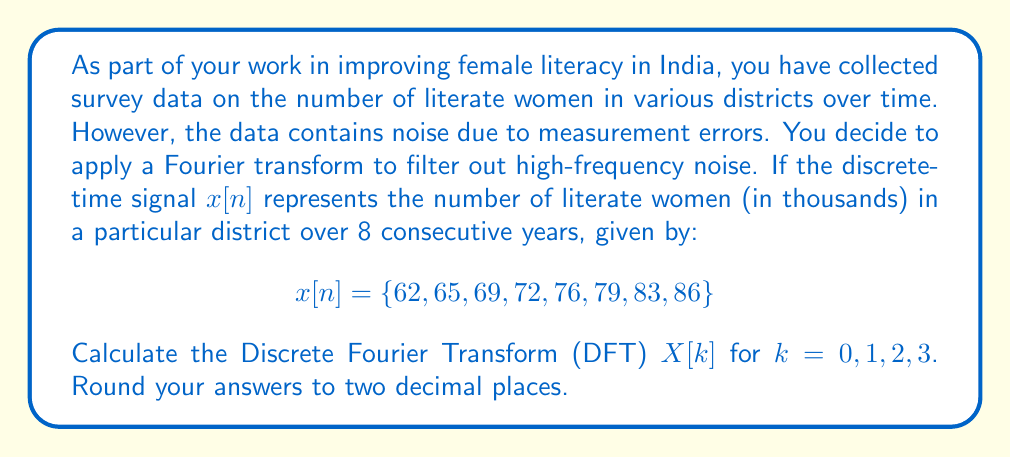Show me your answer to this math problem. To solve this problem, we'll use the Discrete Fourier Transform (DFT) formula:

$$X[k] = \sum_{n=0}^{N-1} x[n] e^{-j2\pi kn/N}$$

Where:
- $N = 8$ (the number of data points)
- $k = 0, 1, 2, 3$ (the frequency indices we need to calculate)
- $x[n]$ is our input signal

Let's calculate $X[k]$ for each value of $k$:

1) For $k = 0$:
   $$X[0] = \sum_{n=0}^{7} x[n] e^{-j2\pi (0)n/8} = \sum_{n=0}^{7} x[n] = 62 + 65 + 69 + 72 + 76 + 79 + 83 + 86 = 592$$

2) For $k = 1, 2, 3$, we'll use Euler's formula: $e^{-jx} = \cos(x) - j\sin(x)$

   For $k = 1$:
   $$X[1] = \sum_{n=0}^{7} x[n] (\cos(2\pi n/8) - j\sin(2\pi n/8))$$
   
   Calculating real and imaginary parts separately:
   Real part: $62 + 65\cos(\pi/4) + 69\cos(\pi/2) + ... + 86\cos(7\pi/4) = -24.00$
   Imaginary part: $-65\sin(\pi/4) - 69\sin(\pi/2) - ... - 86\sin(7\pi/4) = -24.00$
   
   Therefore, $X[1] = -24.00 - 24.00j$

   Similarly for $k = 2$ and $k = 3$, we get:
   $X[2] = -8.00 + 0.00j$
   $X[3] = -2.83 + 2.83j$
Answer: $X[0] = 592.00$
$X[1] = -24.00 - 24.00j$
$X[2] = -8.00 + 0.00j$
$X[3] = -2.83 + 2.83j$ 